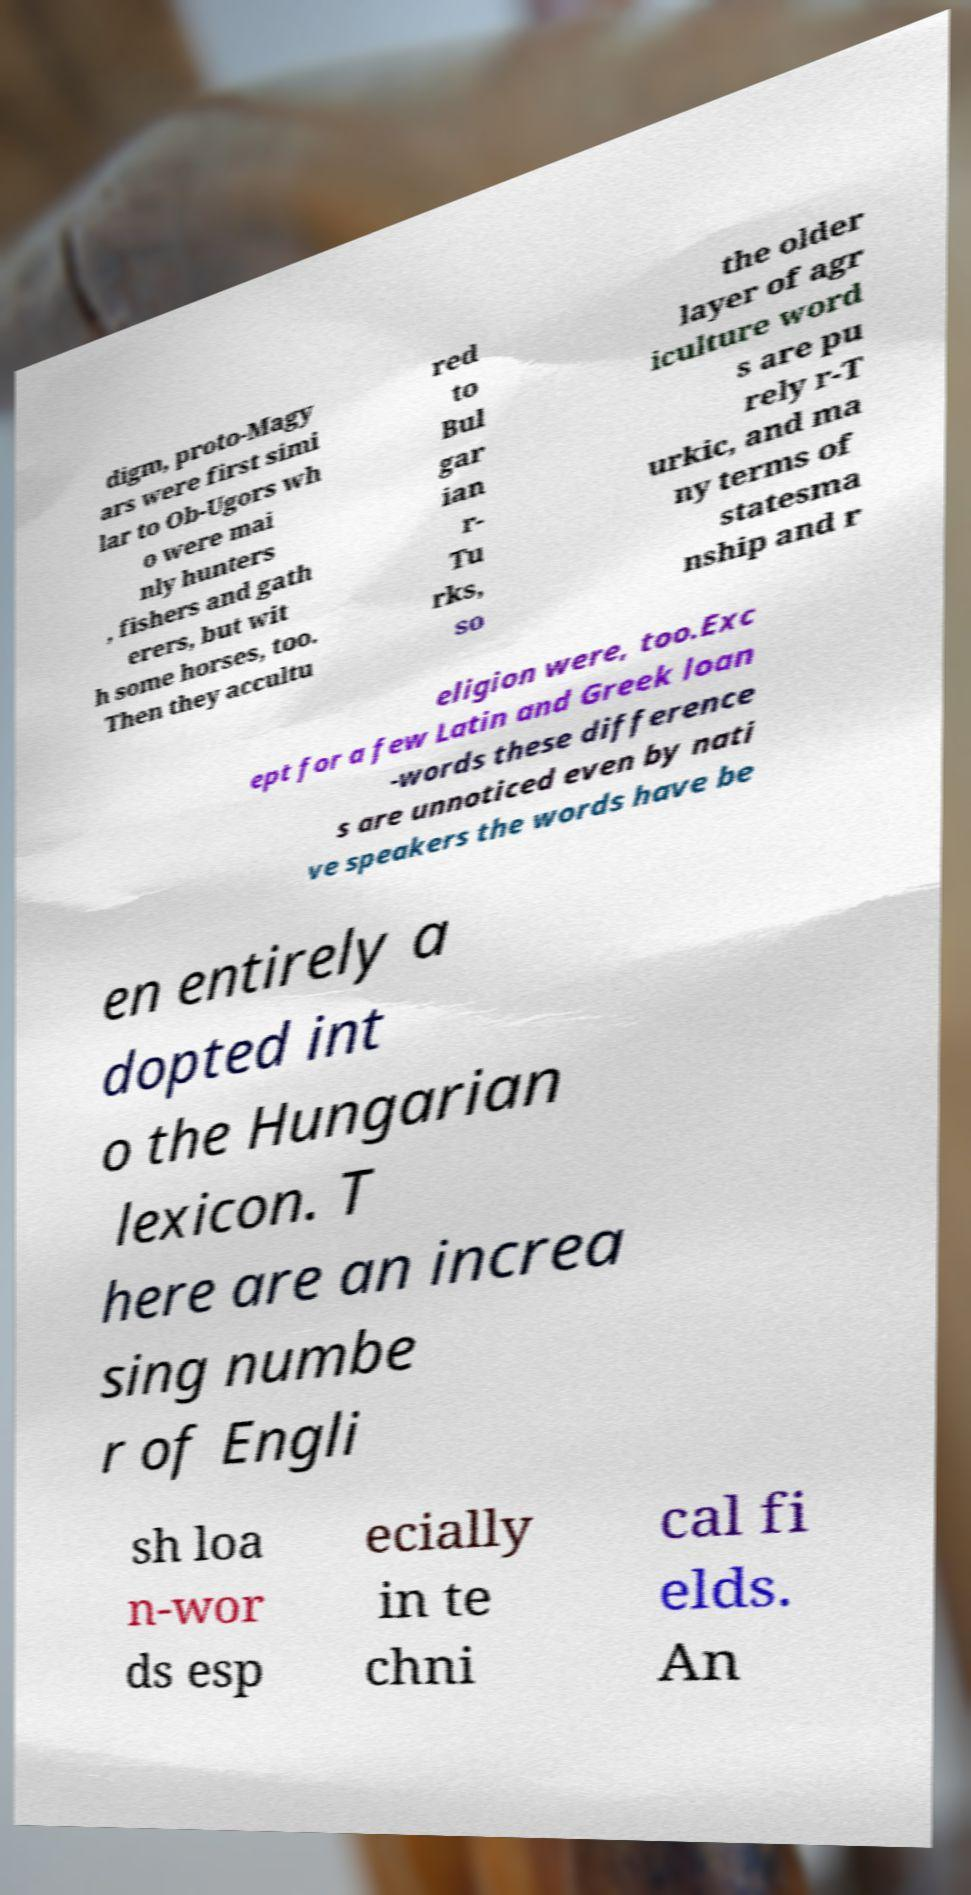Please identify and transcribe the text found in this image. digm, proto-Magy ars were first simi lar to Ob-Ugors wh o were mai nly hunters , fishers and gath erers, but wit h some horses, too. Then they accultu red to Bul gar ian r- Tu rks, so the older layer of agr iculture word s are pu rely r-T urkic, and ma ny terms of statesma nship and r eligion were, too.Exc ept for a few Latin and Greek loan -words these difference s are unnoticed even by nati ve speakers the words have be en entirely a dopted int o the Hungarian lexicon. T here are an increa sing numbe r of Engli sh loa n-wor ds esp ecially in te chni cal fi elds. An 